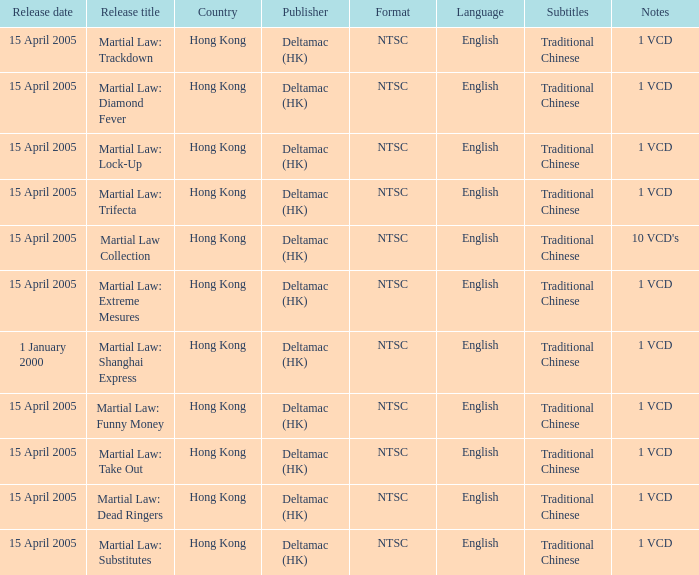Martial law: substitutes was released by which publisher? Deltamac (HK). 